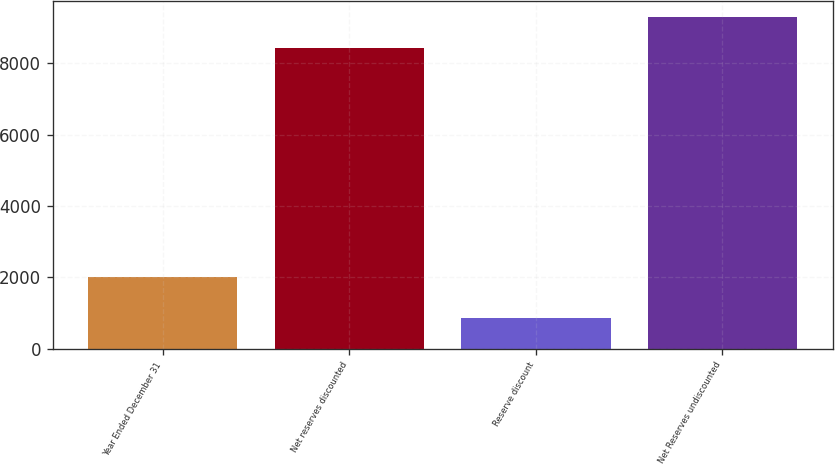Convert chart to OTSL. <chart><loc_0><loc_0><loc_500><loc_500><bar_chart><fcel>Year Ended December 31<fcel>Net reserves discounted<fcel>Reserve discount<fcel>Net Reserves undiscounted<nl><fcel>2012<fcel>8412<fcel>867<fcel>9279<nl></chart> 